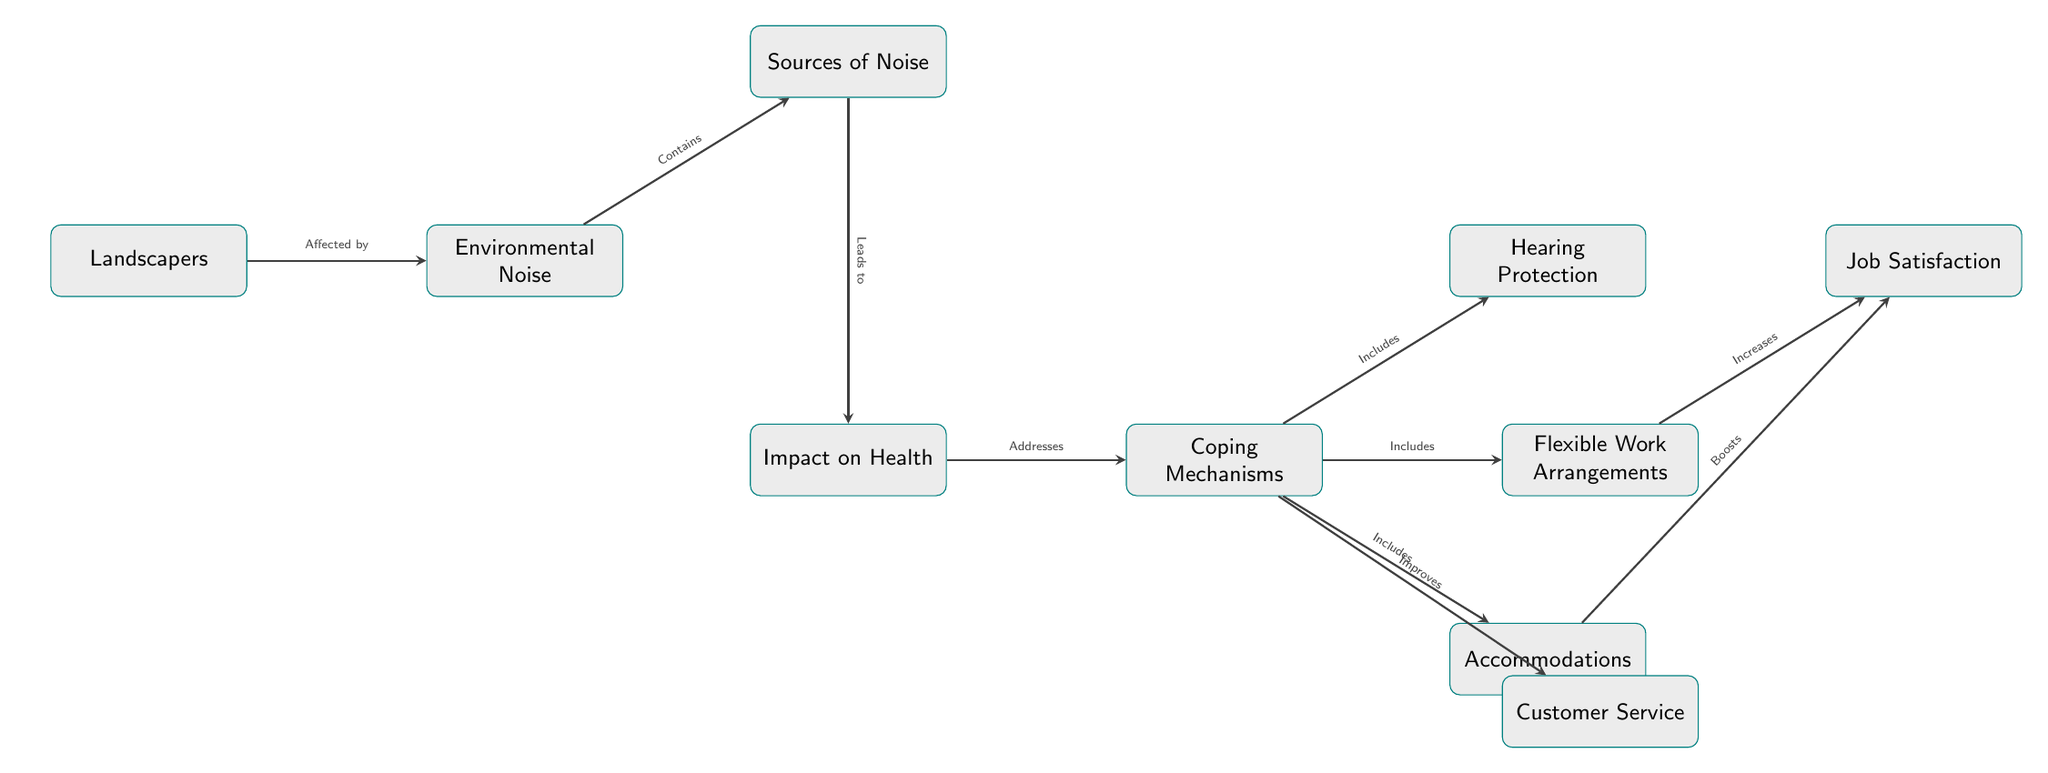What is the main subject of the diagram? The main subject of the diagram is "Landscapers," which is located at the leftmost node in the diagram, serving as the starting point to understand the impact of environmental noise on this group.
Answer: Landscapers How many coping mechanisms are identified in the diagram? The diagram identifies three coping mechanisms: Hearing Protection, Flexible Work Arrangements, and Accommodations. These are all nodes that branch from the "Coping Mechanisms" node.
Answer: Three What leads to "Impact on Health"? The "Sources of Noise" node leads to the "Impact on Health." This can be observed as the next node following the edge from "Sources of Noise" to "Impact on Health."
Answer: Sources of Noise What improves customer service? The diagram shows that "Coping Mechanisms" improves "Customer Service," as indicated by the edge connecting these two nodes.
Answer: Coping Mechanisms What is the relationship between "Flexible Work Arrangements" and "Job Satisfaction"? "Flexible Work Arrangements" increases "Job Satisfaction," as indicated by the edge that directly connects the two nodes with the label "Increases."
Answer: Increases Which node is directly connected to "Environmental Noise"? "Landscapers" is directly connected to "Environmental Noise," indicating that landscapers are affected by this noise. This relationship can be seen through the direct edge between these two nodes.
Answer: Landscapers How many edges are there in total in the diagram? To find the total edges, we count each connection between the nodes. There are seven edges connecting various nodes as displayed on the diagram, linking different concepts together.
Answer: Seven What does "Hearing Protection" fall under? "Hearing Protection" falls under "Coping Mechanisms," which means it is one of the several strategies suggested within the broader category of coping with the effects of noise.
Answer: Coping Mechanisms What effect does "Accommodations" have on "Job Satisfaction"? "Accommodations" boosts "Job Satisfaction," denoting that having accommodations leads to an increase in job satisfaction based on the edge's label.
Answer: Boosts 